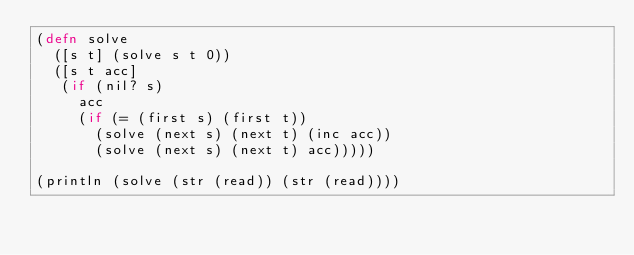<code> <loc_0><loc_0><loc_500><loc_500><_Clojure_>(defn solve
  ([s t] (solve s t 0))
  ([s t acc]
   (if (nil? s)
     acc
     (if (= (first s) (first t))
       (solve (next s) (next t) (inc acc))
       (solve (next s) (next t) acc)))))

(println (solve (str (read)) (str (read))))
</code> 